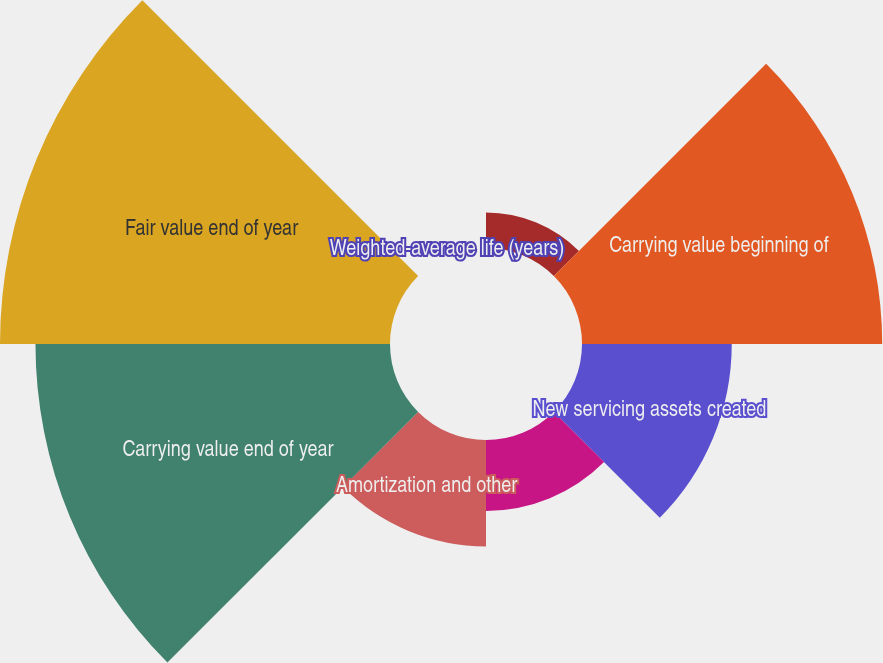Convert chart to OTSL. <chart><loc_0><loc_0><loc_500><loc_500><pie_chart><fcel>Amortization Method (dollar<fcel>Carrying value beginning of<fcel>New servicing assets created<fcel>Impairment charge<fcel>Amortization and other<fcel>Carrying value end of year<fcel>Fair value end of year<fcel>Weighted-average life (years)<nl><fcel>2.52%<fcel>21.33%<fcel>10.64%<fcel>5.04%<fcel>7.56%<fcel>25.19%<fcel>27.71%<fcel>0.0%<nl></chart> 